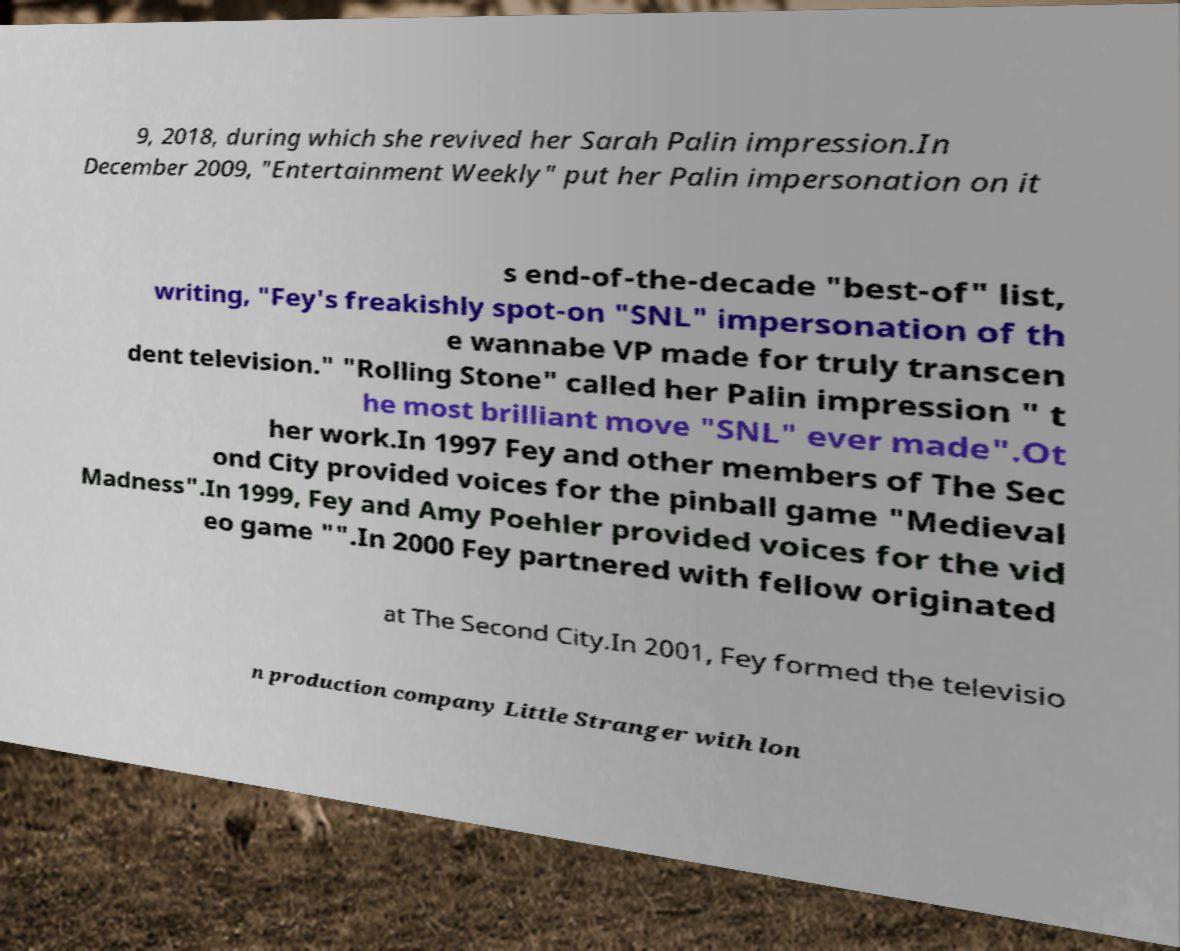Can you read and provide the text displayed in the image?This photo seems to have some interesting text. Can you extract and type it out for me? 9, 2018, during which she revived her Sarah Palin impression.In December 2009, "Entertainment Weekly" put her Palin impersonation on it s end-of-the-decade "best-of" list, writing, "Fey's freakishly spot-on "SNL" impersonation of th e wannabe VP made for truly transcen dent television." "Rolling Stone" called her Palin impression " t he most brilliant move "SNL" ever made".Ot her work.In 1997 Fey and other members of The Sec ond City provided voices for the pinball game "Medieval Madness".In 1999, Fey and Amy Poehler provided voices for the vid eo game "".In 2000 Fey partnered with fellow originated at The Second City.In 2001, Fey formed the televisio n production company Little Stranger with lon 